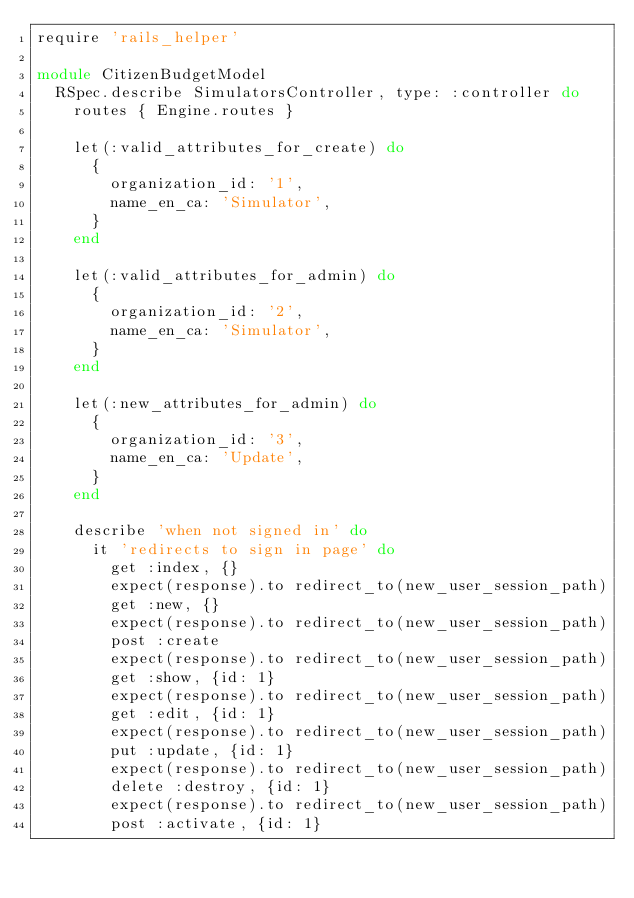<code> <loc_0><loc_0><loc_500><loc_500><_Ruby_>require 'rails_helper'

module CitizenBudgetModel
  RSpec.describe SimulatorsController, type: :controller do
    routes { Engine.routes }

    let(:valid_attributes_for_create) do
      {
        organization_id: '1',
        name_en_ca: 'Simulator',
      }
    end

    let(:valid_attributes_for_admin) do
      {
        organization_id: '2',
        name_en_ca: 'Simulator',
      }
    end

    let(:new_attributes_for_admin) do
      {
        organization_id: '3',
        name_en_ca: 'Update',
      }
    end

    describe 'when not signed in' do
      it 'redirects to sign in page' do
        get :index, {}
        expect(response).to redirect_to(new_user_session_path)
        get :new, {}
        expect(response).to redirect_to(new_user_session_path)
        post :create
        expect(response).to redirect_to(new_user_session_path)
        get :show, {id: 1}
        expect(response).to redirect_to(new_user_session_path)
        get :edit, {id: 1}
        expect(response).to redirect_to(new_user_session_path)
        put :update, {id: 1}
        expect(response).to redirect_to(new_user_session_path)
        delete :destroy, {id: 1}
        expect(response).to redirect_to(new_user_session_path)
        post :activate, {id: 1}</code> 